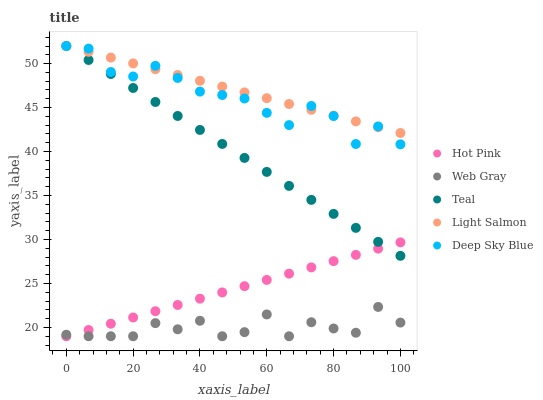Does Web Gray have the minimum area under the curve?
Answer yes or no. Yes. Does Light Salmon have the maximum area under the curve?
Answer yes or no. Yes. Does Hot Pink have the minimum area under the curve?
Answer yes or no. No. Does Hot Pink have the maximum area under the curve?
Answer yes or no. No. Is Hot Pink the smoothest?
Answer yes or no. Yes. Is Web Gray the roughest?
Answer yes or no. Yes. Is Web Gray the smoothest?
Answer yes or no. No. Is Hot Pink the roughest?
Answer yes or no. No. Does Hot Pink have the lowest value?
Answer yes or no. Yes. Does Deep Sky Blue have the lowest value?
Answer yes or no. No. Does Teal have the highest value?
Answer yes or no. Yes. Does Hot Pink have the highest value?
Answer yes or no. No. Is Hot Pink less than Deep Sky Blue?
Answer yes or no. Yes. Is Deep Sky Blue greater than Web Gray?
Answer yes or no. Yes. Does Hot Pink intersect Teal?
Answer yes or no. Yes. Is Hot Pink less than Teal?
Answer yes or no. No. Is Hot Pink greater than Teal?
Answer yes or no. No. Does Hot Pink intersect Deep Sky Blue?
Answer yes or no. No. 